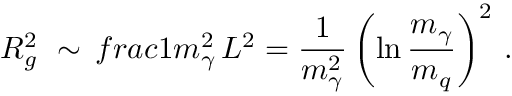Convert formula to latex. <formula><loc_0><loc_0><loc_500><loc_500>R _ { g } ^ { 2 } \ \sim \, f r a c { 1 } { m _ { \gamma } ^ { 2 } } \, L ^ { 2 } = \frac { 1 } { m _ { \gamma } ^ { 2 } } \left ( \ln \frac { m _ { \gamma } } { m _ { q } } \right ) ^ { 2 } \, .</formula> 